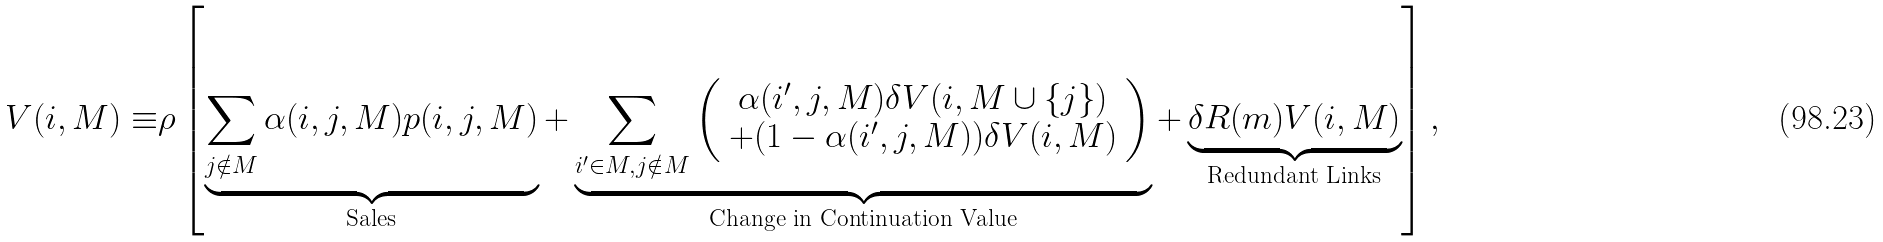<formula> <loc_0><loc_0><loc_500><loc_500>V ( i , M ) \equiv & \rho \left [ \underbrace { \sum _ { j \notin M } \alpha ( i , j , M ) p ( i , j , M ) } _ { \text {Sales} } + \underbrace { \sum _ { i ^ { \prime } \in M , j \notin M } \left ( \begin{array} { c } \alpha ( i ^ { \prime } , j , M ) \delta V ( i , M \cup \{ j \} ) \\ + ( 1 - \alpha ( i ^ { \prime } , j , M ) ) \delta V ( i , M ) \end{array} \right ) } _ { \text {Change in Continuation Value} } + \underbrace { \delta R ( m ) V ( i , M ) } _ { \text {Redundant Links} } \right ] ,</formula> 